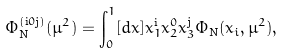Convert formula to latex. <formula><loc_0><loc_0><loc_500><loc_500>\Phi _ { \text {N} } ^ { ( \text {i} 0 \text {j} ) } ( \mu ^ { 2 } ) = \int _ { 0 } ^ { 1 } [ d x ] x _ { 1 } ^ { \text {i} } x _ { 2 } ^ { 0 } x _ { 3 } ^ { \text {j} } \Phi _ { \text {N} } ( x _ { i } , \mu ^ { 2 } ) ,</formula> 